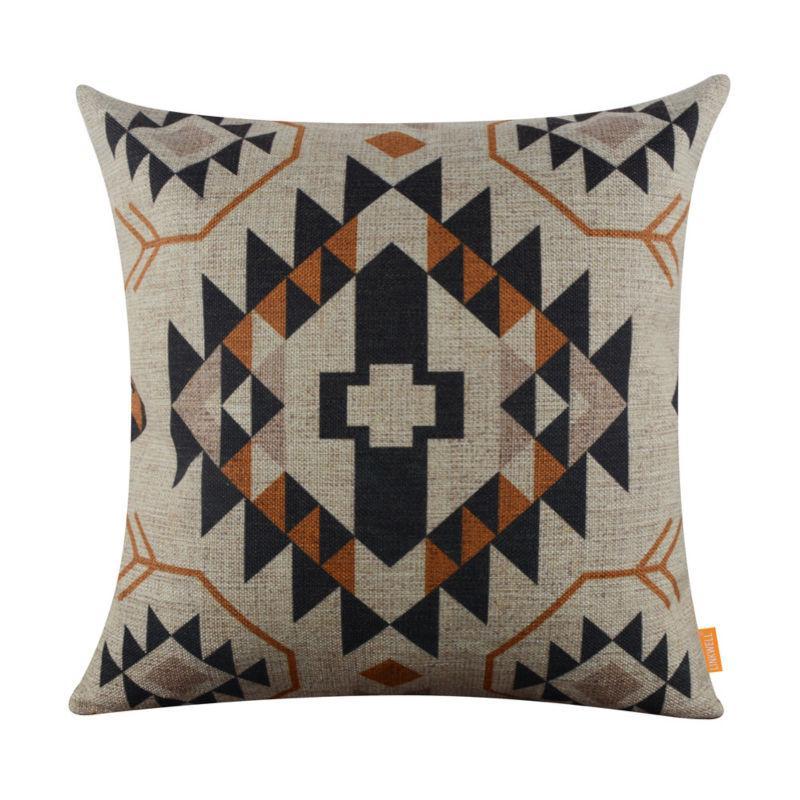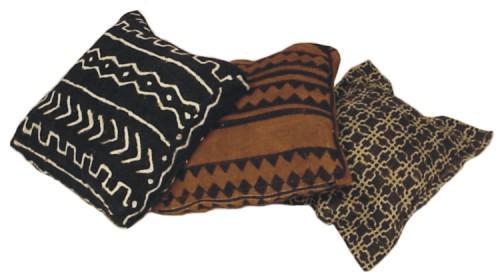The first image is the image on the left, the second image is the image on the right. For the images shown, is this caption "There are three pillows in the two images." true? Answer yes or no. No. The first image is the image on the left, the second image is the image on the right. Evaluate the accuracy of this statement regarding the images: "All pillows feature a graphic print resembling a maze, and no image contains multiple pillows that don't match.". Is it true? Answer yes or no. No. 